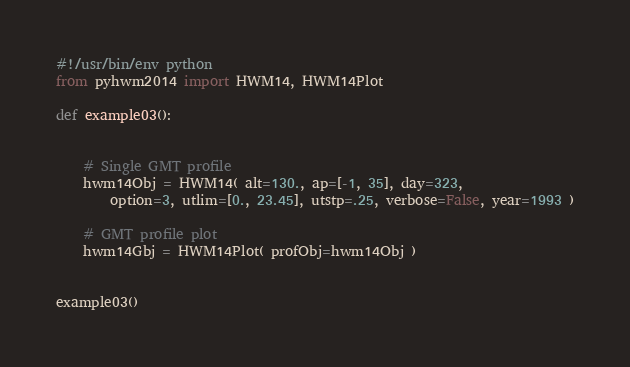Convert code to text. <code><loc_0><loc_0><loc_500><loc_500><_Python_>#!/usr/bin/env python
from pyhwm2014 import HWM14, HWM14Plot

def example03():


    # Single GMT profile
    hwm14Obj = HWM14( alt=130., ap=[-1, 35], day=323,
        option=3, utlim=[0., 23.45], utstp=.25, verbose=False, year=1993 )

    # GMT profile plot
    hwm14Gbj = HWM14Plot( profObj=hwm14Obj )


example03()
</code> 